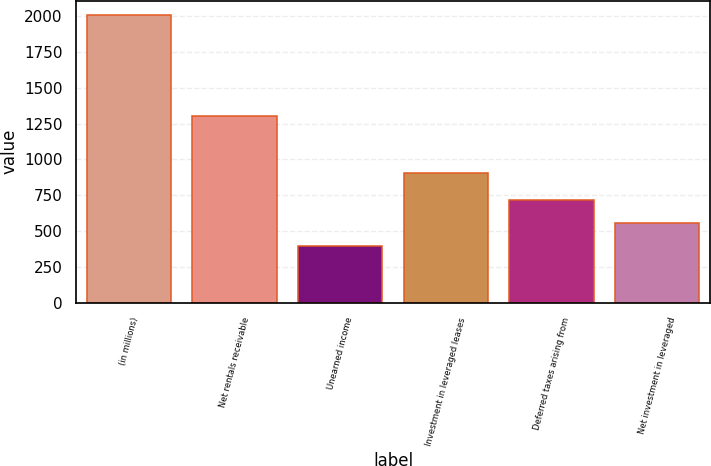Convert chart. <chart><loc_0><loc_0><loc_500><loc_500><bar_chart><fcel>(in millions)<fcel>Net rentals receivable<fcel>Unearned income<fcel>Investment in leveraged leases<fcel>Deferred taxes arising from<fcel>Net investment in leveraged<nl><fcel>2006<fcel>1299<fcel>396<fcel>903<fcel>718<fcel>557<nl></chart> 